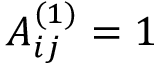<formula> <loc_0><loc_0><loc_500><loc_500>A _ { i j } ^ { ( 1 ) } = 1</formula> 